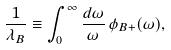Convert formula to latex. <formula><loc_0><loc_0><loc_500><loc_500>\frac { 1 } { \lambda _ { B } } \equiv \int _ { 0 } ^ { \infty } \frac { d \omega } { \omega } \, \phi _ { B + } ( \omega ) ,</formula> 